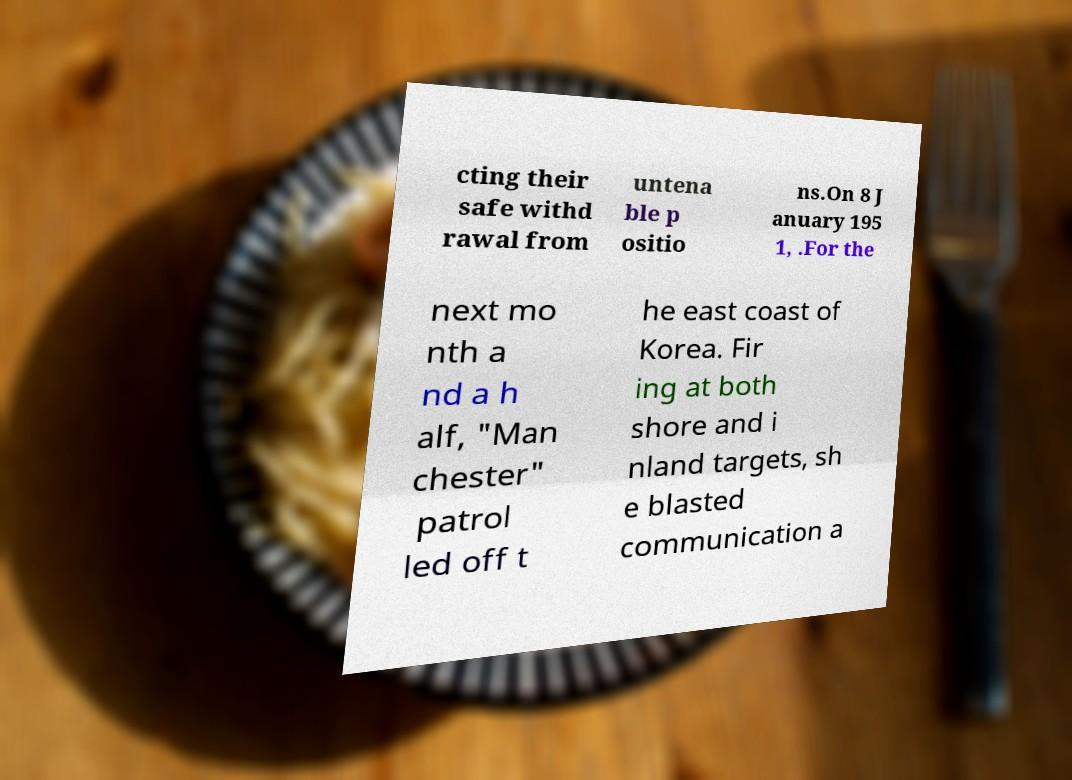Please read and relay the text visible in this image. What does it say? cting their safe withd rawal from untena ble p ositio ns.On 8 J anuary 195 1, .For the next mo nth a nd a h alf, "Man chester" patrol led off t he east coast of Korea. Fir ing at both shore and i nland targets, sh e blasted communication a 